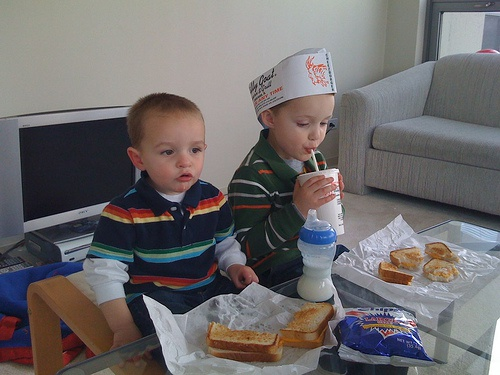Describe the objects in this image and their specific colors. I can see people in gray, black, and maroon tones, couch in gray tones, people in gray, black, and darkgray tones, tv in gray, black, and darkgray tones, and dining table in gray, darkgray, and black tones in this image. 